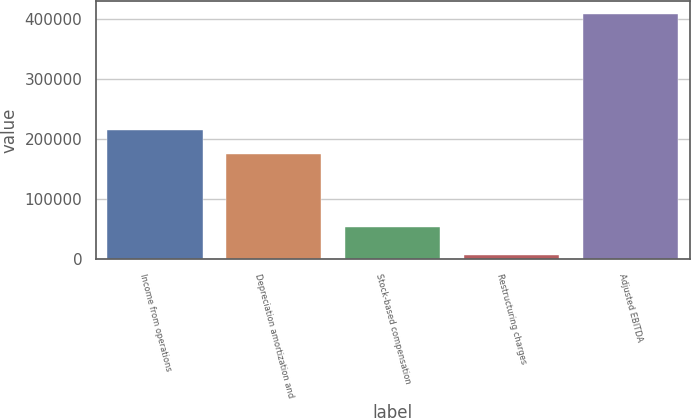Convert chart to OTSL. <chart><loc_0><loc_0><loc_500><loc_500><bar_chart><fcel>Income from operations<fcel>Depreciation amortization and<fcel>Stock-based compensation<fcel>Restructuring charges<fcel>Adjusted EBITDA<nl><fcel>215626<fcel>175371<fcel>53056<fcel>6053<fcel>408608<nl></chart> 